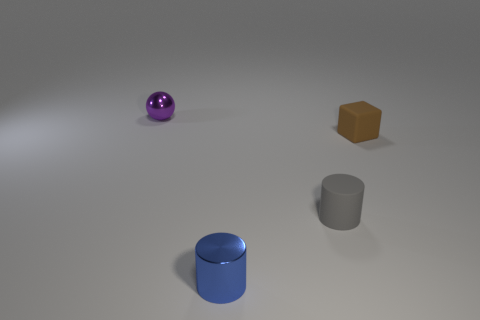Add 4 gray objects. How many objects exist? 8 Subtract all cubes. How many objects are left? 3 Subtract 0 cyan cylinders. How many objects are left? 4 Subtract all blue blocks. Subtract all gray objects. How many objects are left? 3 Add 4 cubes. How many cubes are left? 5 Add 1 blue objects. How many blue objects exist? 2 